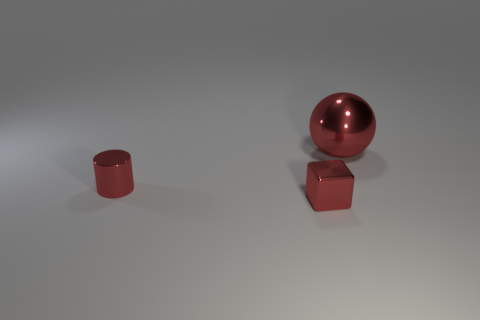Add 1 big matte cubes. How many objects exist? 4 Subtract all cubes. How many objects are left? 2 Subtract 0 purple cylinders. How many objects are left? 3 Subtract all cyan things. Subtract all tiny red metal cylinders. How many objects are left? 2 Add 1 tiny red cylinders. How many tiny red cylinders are left? 2 Add 3 gray rubber blocks. How many gray rubber blocks exist? 3 